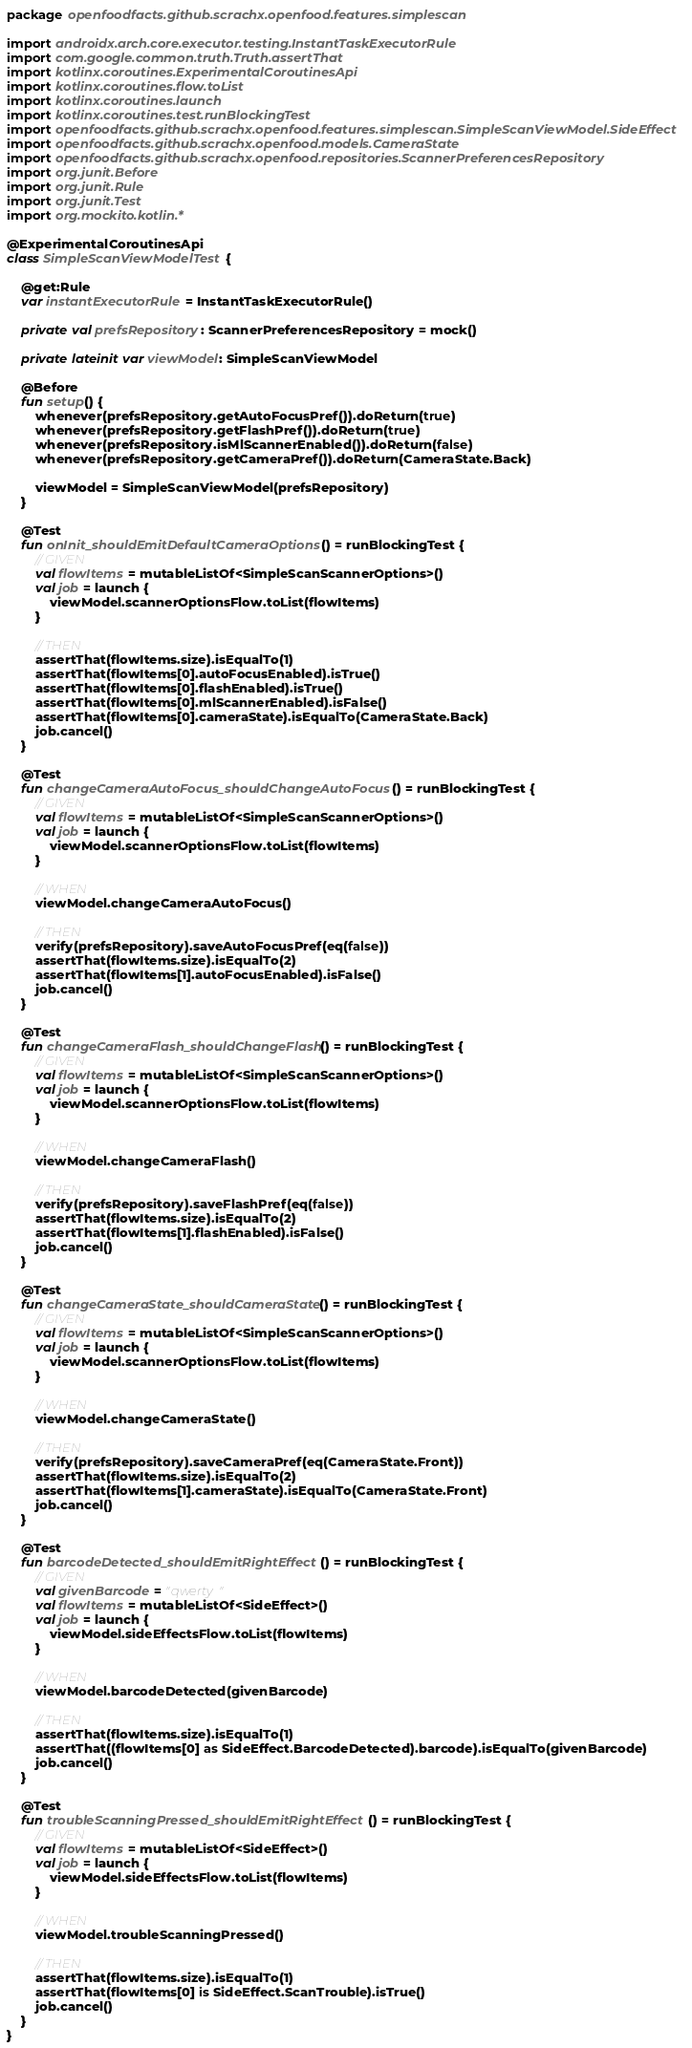<code> <loc_0><loc_0><loc_500><loc_500><_Kotlin_>package openfoodfacts.github.scrachx.openfood.features.simplescan

import androidx.arch.core.executor.testing.InstantTaskExecutorRule
import com.google.common.truth.Truth.assertThat
import kotlinx.coroutines.ExperimentalCoroutinesApi
import kotlinx.coroutines.flow.toList
import kotlinx.coroutines.launch
import kotlinx.coroutines.test.runBlockingTest
import openfoodfacts.github.scrachx.openfood.features.simplescan.SimpleScanViewModel.SideEffect
import openfoodfacts.github.scrachx.openfood.models.CameraState
import openfoodfacts.github.scrachx.openfood.repositories.ScannerPreferencesRepository
import org.junit.Before
import org.junit.Rule
import org.junit.Test
import org.mockito.kotlin.*

@ExperimentalCoroutinesApi
class SimpleScanViewModelTest {

    @get:Rule
    var instantExecutorRule = InstantTaskExecutorRule()

    private val prefsRepository: ScannerPreferencesRepository = mock()

    private lateinit var viewModel: SimpleScanViewModel

    @Before
    fun setup() {
        whenever(prefsRepository.getAutoFocusPref()).doReturn(true)
        whenever(prefsRepository.getFlashPref()).doReturn(true)
        whenever(prefsRepository.isMlScannerEnabled()).doReturn(false)
        whenever(prefsRepository.getCameraPref()).doReturn(CameraState.Back)

        viewModel = SimpleScanViewModel(prefsRepository)
    }

    @Test
    fun onInit_shouldEmitDefaultCameraOptions() = runBlockingTest {
        // GIVEN
        val flowItems = mutableListOf<SimpleScanScannerOptions>()
        val job = launch {
            viewModel.scannerOptionsFlow.toList(flowItems)
        }

        // THEN
        assertThat(flowItems.size).isEqualTo(1)
        assertThat(flowItems[0].autoFocusEnabled).isTrue()
        assertThat(flowItems[0].flashEnabled).isTrue()
        assertThat(flowItems[0].mlScannerEnabled).isFalse()
        assertThat(flowItems[0].cameraState).isEqualTo(CameraState.Back)
        job.cancel()
    }

    @Test
    fun changeCameraAutoFocus_shouldChangeAutoFocus() = runBlockingTest {
        // GIVEN
        val flowItems = mutableListOf<SimpleScanScannerOptions>()
        val job = launch {
            viewModel.scannerOptionsFlow.toList(flowItems)
        }

        // WHEN
        viewModel.changeCameraAutoFocus()

        // THEN
        verify(prefsRepository).saveAutoFocusPref(eq(false))
        assertThat(flowItems.size).isEqualTo(2)
        assertThat(flowItems[1].autoFocusEnabled).isFalse()
        job.cancel()
    }

    @Test
    fun changeCameraFlash_shouldChangeFlash() = runBlockingTest {
        // GIVEN
        val flowItems = mutableListOf<SimpleScanScannerOptions>()
        val job = launch {
            viewModel.scannerOptionsFlow.toList(flowItems)
        }

        // WHEN
        viewModel.changeCameraFlash()

        // THEN
        verify(prefsRepository).saveFlashPref(eq(false))
        assertThat(flowItems.size).isEqualTo(2)
        assertThat(flowItems[1].flashEnabled).isFalse()
        job.cancel()
    }

    @Test
    fun changeCameraState_shouldCameraState() = runBlockingTest {
        // GIVEN
        val flowItems = mutableListOf<SimpleScanScannerOptions>()
        val job = launch {
            viewModel.scannerOptionsFlow.toList(flowItems)
        }

        // WHEN
        viewModel.changeCameraState()

        // THEN
        verify(prefsRepository).saveCameraPref(eq(CameraState.Front))
        assertThat(flowItems.size).isEqualTo(2)
        assertThat(flowItems[1].cameraState).isEqualTo(CameraState.Front)
        job.cancel()
    }

    @Test
    fun barcodeDetected_shouldEmitRightEffect() = runBlockingTest {
        // GIVEN
        val givenBarcode = "qwerty"
        val flowItems = mutableListOf<SideEffect>()
        val job = launch {
            viewModel.sideEffectsFlow.toList(flowItems)
        }

        // WHEN
        viewModel.barcodeDetected(givenBarcode)

        // THEN
        assertThat(flowItems.size).isEqualTo(1)
        assertThat((flowItems[0] as SideEffect.BarcodeDetected).barcode).isEqualTo(givenBarcode)
        job.cancel()
    }

    @Test
    fun troubleScanningPressed_shouldEmitRightEffect() = runBlockingTest {
        // GIVEN
        val flowItems = mutableListOf<SideEffect>()
        val job = launch {
            viewModel.sideEffectsFlow.toList(flowItems)
        }

        // WHEN
        viewModel.troubleScanningPressed()

        // THEN
        assertThat(flowItems.size).isEqualTo(1)
        assertThat(flowItems[0] is SideEffect.ScanTrouble).isTrue()
        job.cancel()
    }
}
</code> 